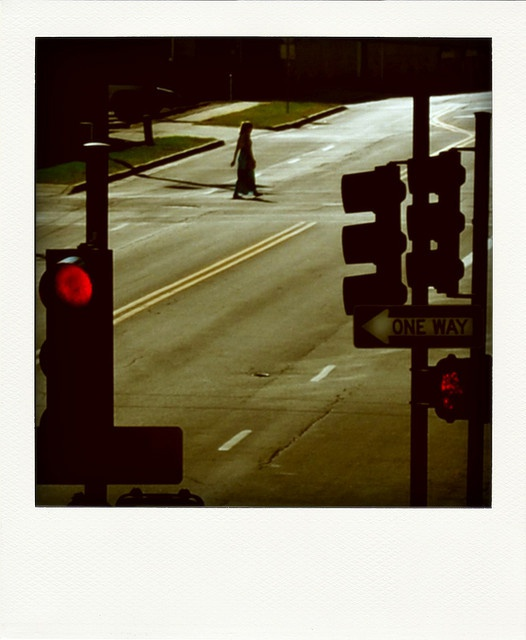Describe the objects in this image and their specific colors. I can see traffic light in lightgray, black, maroon, and red tones, traffic light in lightgray, black, and olive tones, traffic light in lightgray, black, and olive tones, traffic light in lightgray, black, olive, and maroon tones, and people in lightgray, black, olive, and darkgray tones in this image. 